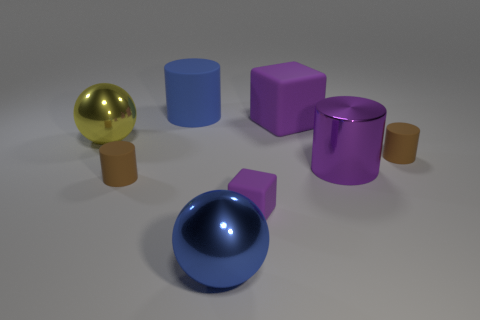There is a ball left of the blue matte thing; does it have the same size as the large blue cylinder?
Make the answer very short. Yes. Are there fewer purple blocks that are right of the big purple metal thing than objects that are left of the large yellow sphere?
Offer a very short reply. No. Is the small cube the same color as the large matte cube?
Your answer should be very brief. Yes. Are there fewer rubber cylinders behind the large yellow shiny ball than big purple matte objects?
Provide a short and direct response. No. There is a big object that is the same color as the large rubber cube; what is it made of?
Make the answer very short. Metal. Is the material of the large purple block the same as the blue cylinder?
Provide a short and direct response. Yes. What number of tiny brown cylinders are the same material as the big purple cylinder?
Provide a short and direct response. 0. What is the color of the big thing that is made of the same material as the large purple cube?
Your answer should be very brief. Blue. What shape is the big blue rubber thing?
Your answer should be compact. Cylinder. There is a brown thing to the left of the big blue cylinder; what material is it?
Provide a short and direct response. Rubber. 